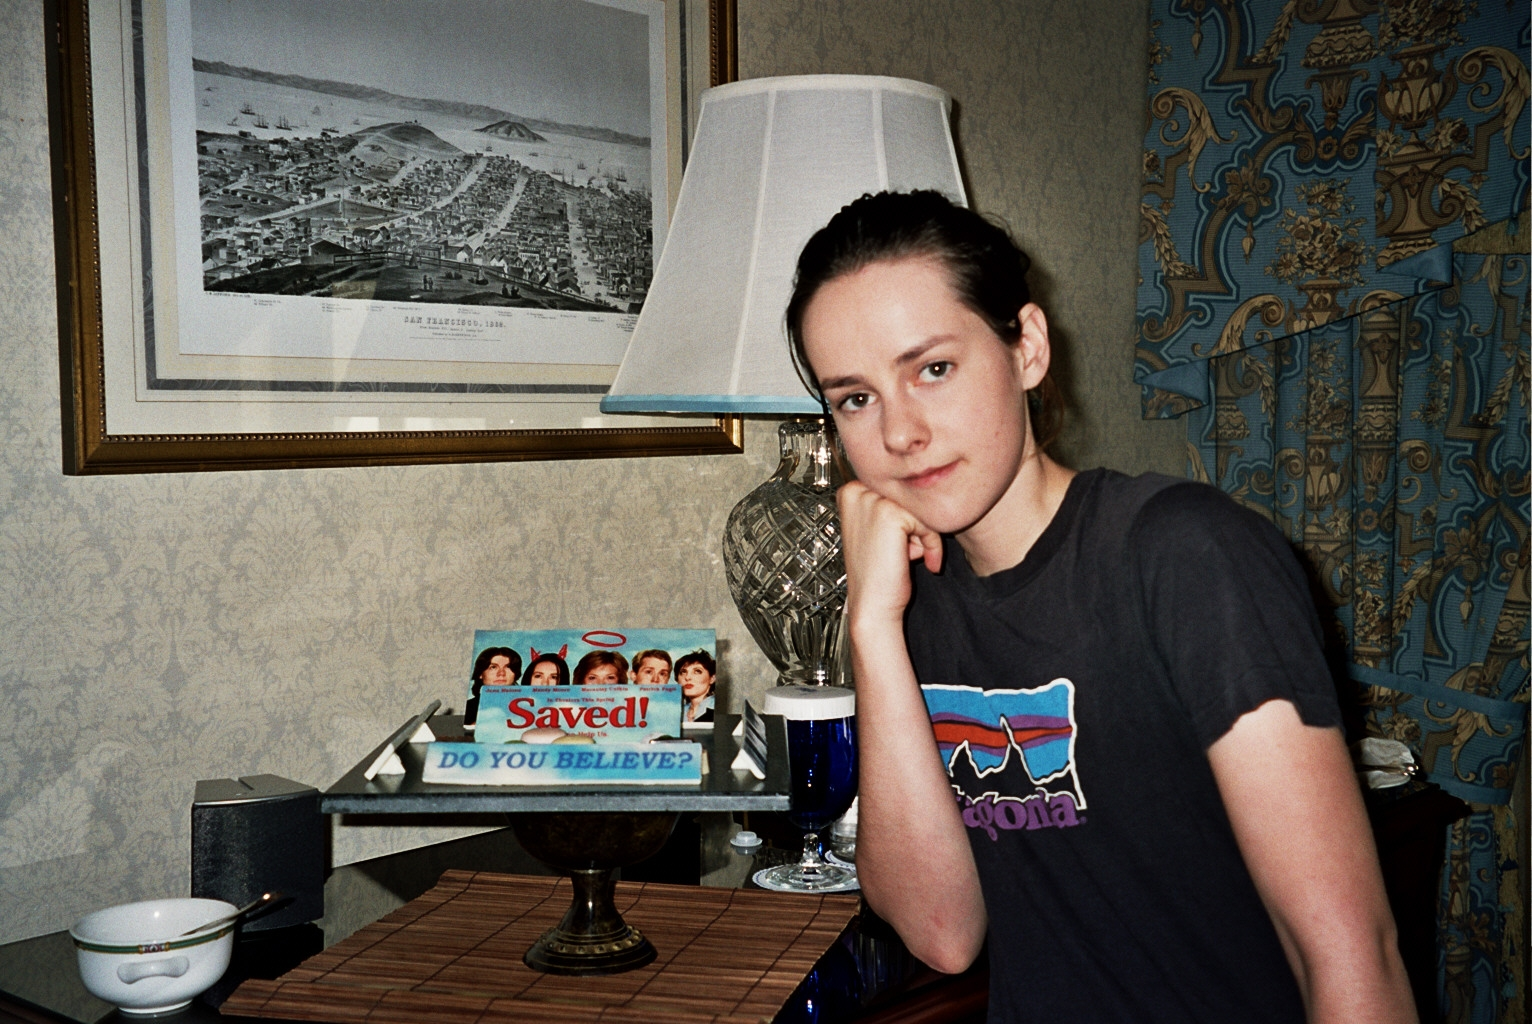What historical context can we gather from the framed artwork on the wall? The framed black-and-white illustration on the wall is a historical map of San Francisco from 1884. This indicates a sense of historical appreciation and gives the room a scholarly touch. Such artwork could be a nod to the rich history of the city and may suggest an interest in historical studies or geography by the inhabitants. 